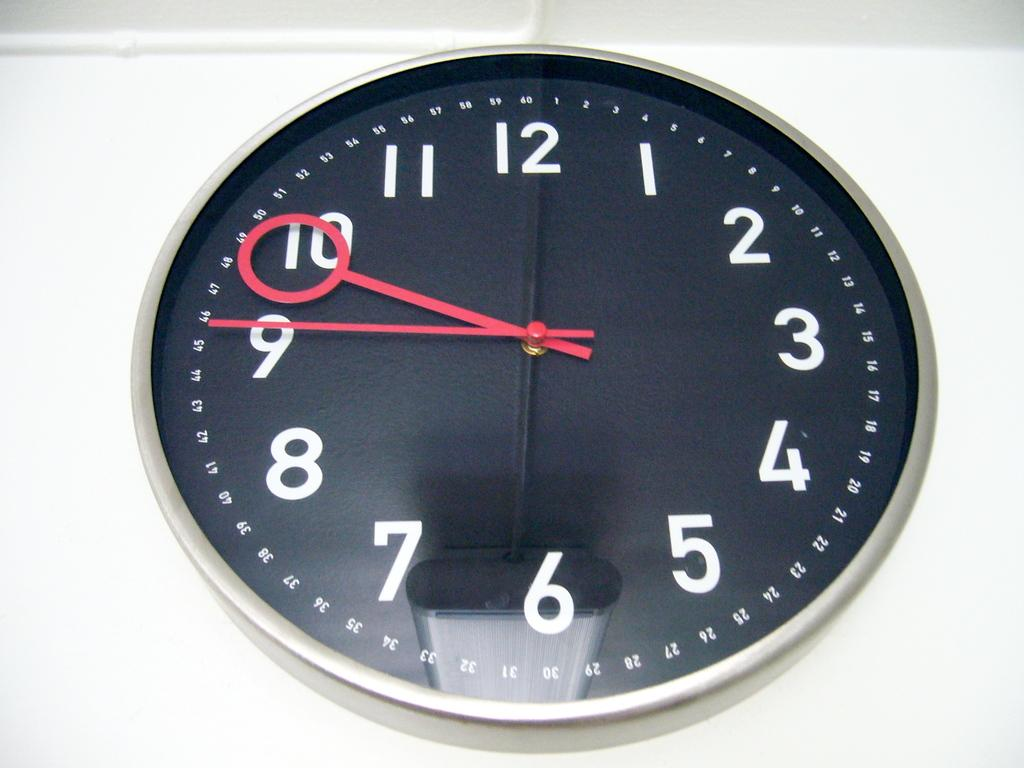<image>
Provide a brief description of the given image. A clock with red hands is showing the time 9:45. 